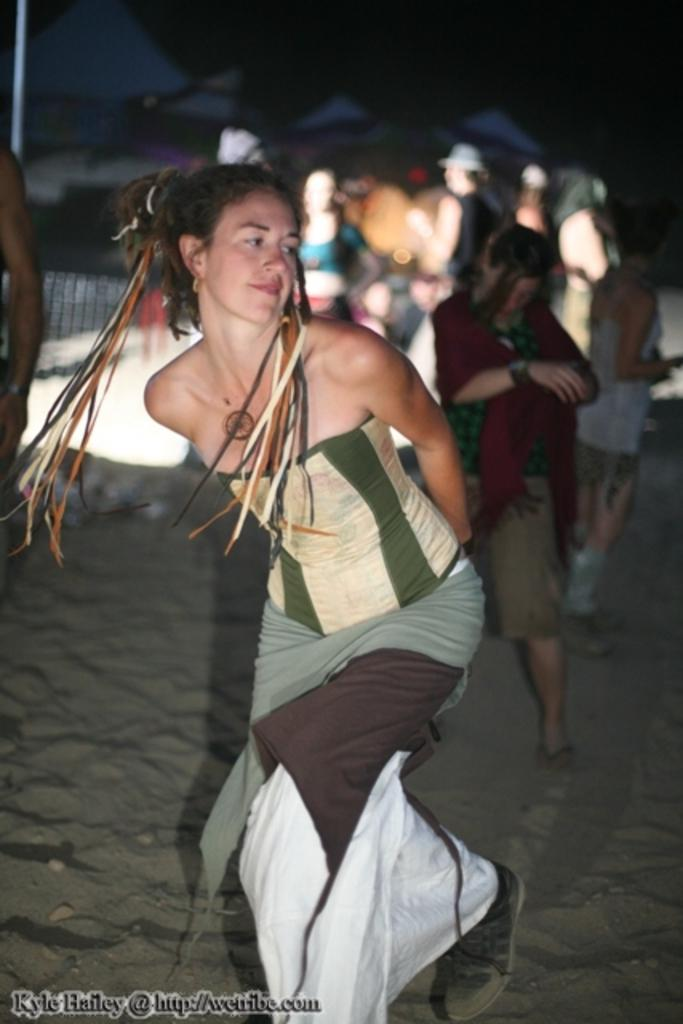Who is the main subject in the image? There is a girl in the image. What is the girl doing in the image? The girl is dancing in the sand. Can you describe the background of the image? There are people standing in the background of the image, and the ground is visible. What type of duck can be seen carrying a tray in the image? There is no duck or tray present in the image. How many bananas are visible in the image? There are no bananas visible in the image. 